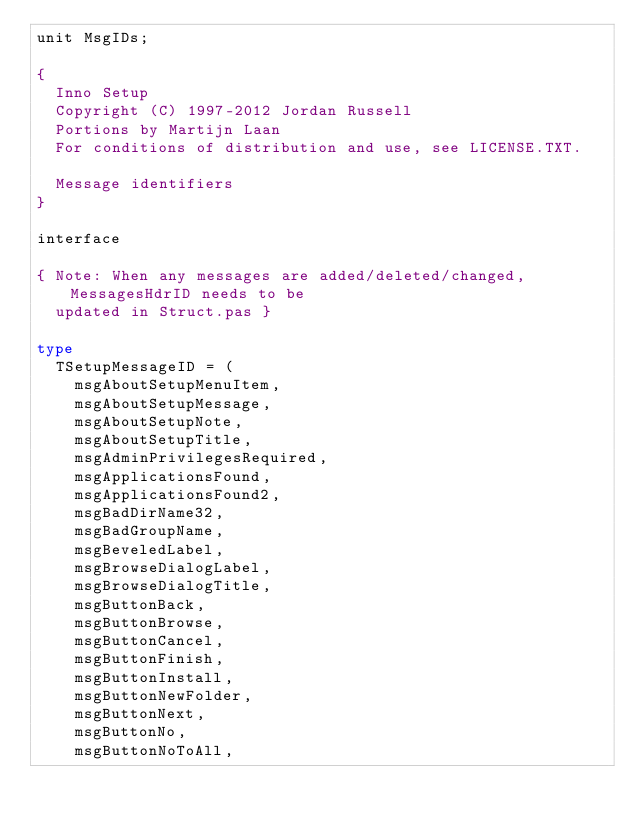Convert code to text. <code><loc_0><loc_0><loc_500><loc_500><_Pascal_>unit MsgIDs;

{
  Inno Setup
  Copyright (C) 1997-2012 Jordan Russell
  Portions by Martijn Laan
  For conditions of distribution and use, see LICENSE.TXT.

  Message identifiers
}

interface

{ Note: When any messages are added/deleted/changed, MessagesHdrID needs to be
  updated in Struct.pas }

type
  TSetupMessageID = (
    msgAboutSetupMenuItem,
    msgAboutSetupMessage,
    msgAboutSetupNote,
    msgAboutSetupTitle,
    msgAdminPrivilegesRequired,
    msgApplicationsFound,
    msgApplicationsFound2,
    msgBadDirName32,
    msgBadGroupName,
    msgBeveledLabel,
    msgBrowseDialogLabel,
    msgBrowseDialogTitle,
    msgButtonBack,
    msgButtonBrowse,
    msgButtonCancel,
    msgButtonFinish,
    msgButtonInstall,
    msgButtonNewFolder,
    msgButtonNext,
    msgButtonNo,
    msgButtonNoToAll,</code> 